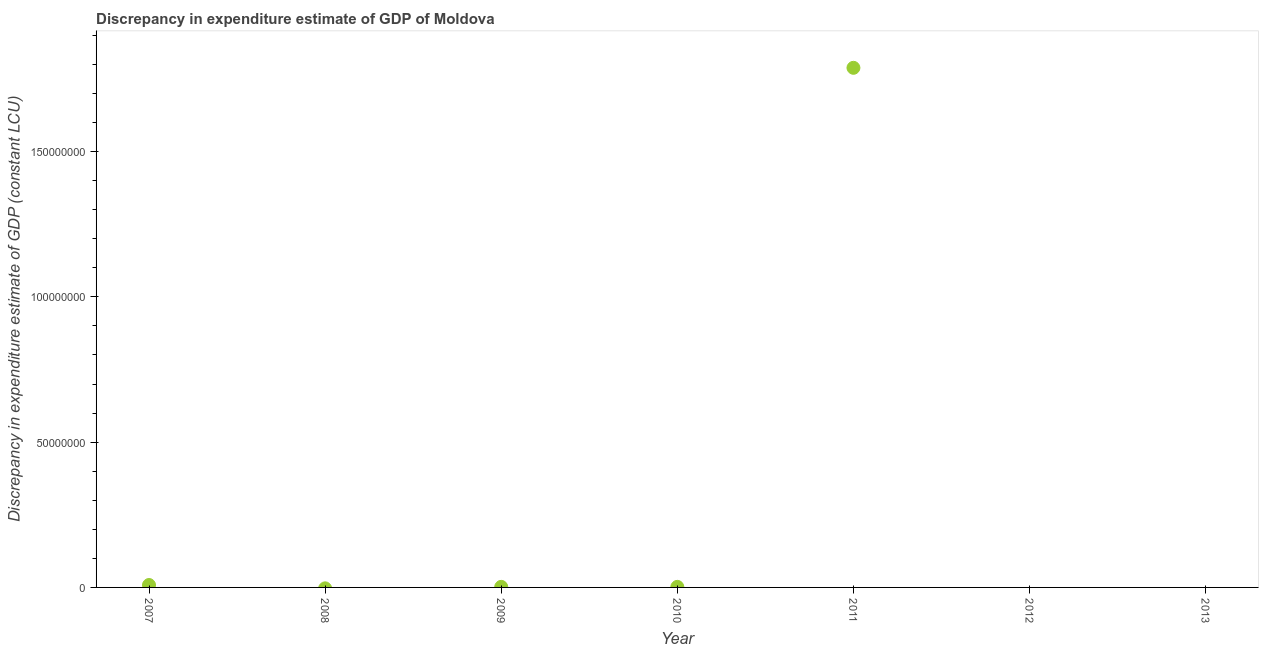What is the discrepancy in expenditure estimate of gdp in 2007?
Ensure brevity in your answer.  8.30e+05. Across all years, what is the maximum discrepancy in expenditure estimate of gdp?
Make the answer very short. 1.79e+08. In which year was the discrepancy in expenditure estimate of gdp maximum?
Make the answer very short. 2011. What is the sum of the discrepancy in expenditure estimate of gdp?
Your answer should be very brief. 1.80e+08. What is the difference between the discrepancy in expenditure estimate of gdp in 2007 and 2011?
Provide a succinct answer. -1.78e+08. What is the average discrepancy in expenditure estimate of gdp per year?
Give a very brief answer. 2.57e+07. What is the median discrepancy in expenditure estimate of gdp?
Offer a very short reply. 1.93e+05. What is the ratio of the discrepancy in expenditure estimate of gdp in 2007 to that in 2009?
Give a very brief answer. 4.26. Is the discrepancy in expenditure estimate of gdp in 2009 less than that in 2011?
Your answer should be compact. Yes. What is the difference between the highest and the second highest discrepancy in expenditure estimate of gdp?
Provide a short and direct response. 1.78e+08. What is the difference between the highest and the lowest discrepancy in expenditure estimate of gdp?
Make the answer very short. 1.79e+08. In how many years, is the discrepancy in expenditure estimate of gdp greater than the average discrepancy in expenditure estimate of gdp taken over all years?
Keep it short and to the point. 1. Does the discrepancy in expenditure estimate of gdp monotonically increase over the years?
Offer a very short reply. No. What is the difference between two consecutive major ticks on the Y-axis?
Your answer should be very brief. 5.00e+07. Does the graph contain any zero values?
Your answer should be compact. Yes. What is the title of the graph?
Your answer should be compact. Discrepancy in expenditure estimate of GDP of Moldova. What is the label or title of the Y-axis?
Provide a succinct answer. Discrepancy in expenditure estimate of GDP (constant LCU). What is the Discrepancy in expenditure estimate of GDP (constant LCU) in 2007?
Give a very brief answer. 8.30e+05. What is the Discrepancy in expenditure estimate of GDP (constant LCU) in 2008?
Your response must be concise. 0. What is the Discrepancy in expenditure estimate of GDP (constant LCU) in 2009?
Keep it short and to the point. 1.95e+05. What is the Discrepancy in expenditure estimate of GDP (constant LCU) in 2010?
Your answer should be very brief. 1.93e+05. What is the Discrepancy in expenditure estimate of GDP (constant LCU) in 2011?
Offer a very short reply. 1.79e+08. What is the Discrepancy in expenditure estimate of GDP (constant LCU) in 2013?
Offer a terse response. 0. What is the difference between the Discrepancy in expenditure estimate of GDP (constant LCU) in 2007 and 2009?
Make the answer very short. 6.35e+05. What is the difference between the Discrepancy in expenditure estimate of GDP (constant LCU) in 2007 and 2010?
Ensure brevity in your answer.  6.37e+05. What is the difference between the Discrepancy in expenditure estimate of GDP (constant LCU) in 2007 and 2011?
Your response must be concise. -1.78e+08. What is the difference between the Discrepancy in expenditure estimate of GDP (constant LCU) in 2009 and 2010?
Your response must be concise. 1800. What is the difference between the Discrepancy in expenditure estimate of GDP (constant LCU) in 2009 and 2011?
Give a very brief answer. -1.79e+08. What is the difference between the Discrepancy in expenditure estimate of GDP (constant LCU) in 2010 and 2011?
Your answer should be very brief. -1.79e+08. What is the ratio of the Discrepancy in expenditure estimate of GDP (constant LCU) in 2007 to that in 2009?
Make the answer very short. 4.26. What is the ratio of the Discrepancy in expenditure estimate of GDP (constant LCU) in 2007 to that in 2010?
Offer a terse response. 4.3. What is the ratio of the Discrepancy in expenditure estimate of GDP (constant LCU) in 2007 to that in 2011?
Keep it short and to the point. 0.01. What is the ratio of the Discrepancy in expenditure estimate of GDP (constant LCU) in 2009 to that in 2011?
Ensure brevity in your answer.  0. What is the ratio of the Discrepancy in expenditure estimate of GDP (constant LCU) in 2010 to that in 2011?
Make the answer very short. 0. 